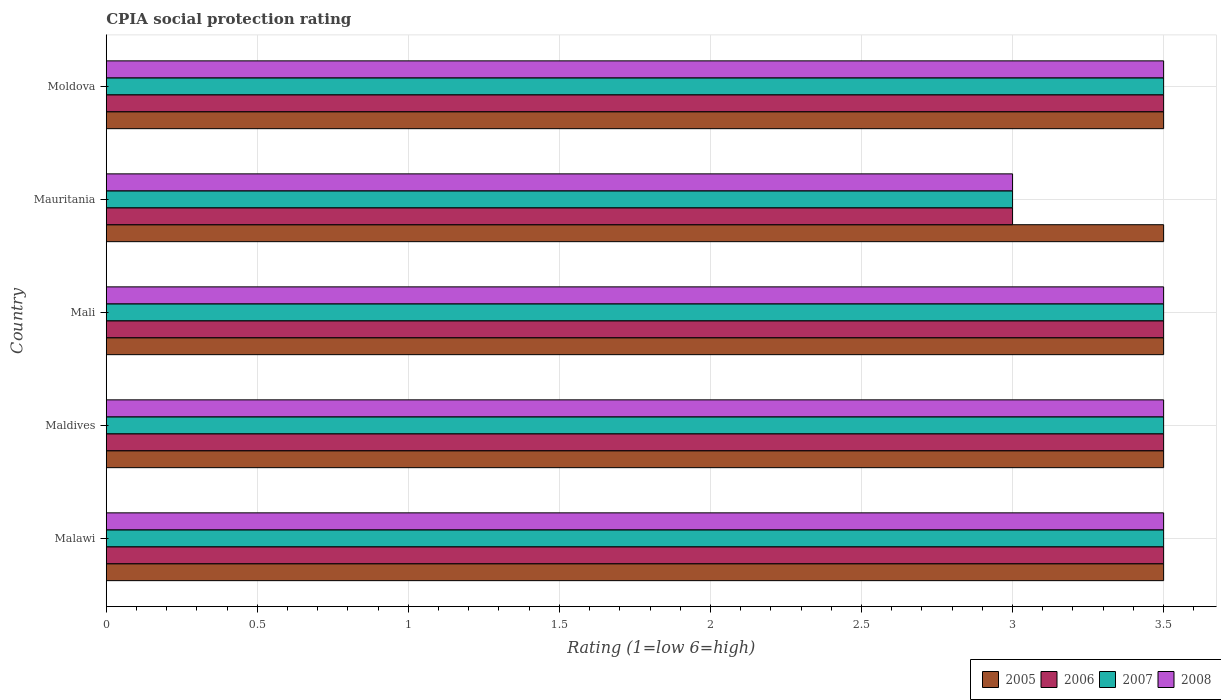Are the number of bars per tick equal to the number of legend labels?
Make the answer very short. Yes. How many bars are there on the 5th tick from the top?
Your response must be concise. 4. How many bars are there on the 2nd tick from the bottom?
Provide a short and direct response. 4. What is the label of the 2nd group of bars from the top?
Your response must be concise. Mauritania. In how many cases, is the number of bars for a given country not equal to the number of legend labels?
Your answer should be compact. 0. What is the CPIA rating in 2006 in Mauritania?
Ensure brevity in your answer.  3. In which country was the CPIA rating in 2006 maximum?
Give a very brief answer. Malawi. In which country was the CPIA rating in 2006 minimum?
Ensure brevity in your answer.  Mauritania. What is the difference between the CPIA rating in 2006 in Mauritania and the CPIA rating in 2005 in Maldives?
Your answer should be compact. -0.5. What is the average CPIA rating in 2005 per country?
Offer a terse response. 3.5. What is the difference between the CPIA rating in 2005 and CPIA rating in 2006 in Malawi?
Keep it short and to the point. 0. Is the CPIA rating in 2008 in Mali less than that in Mauritania?
Give a very brief answer. No. In how many countries, is the CPIA rating in 2007 greater than the average CPIA rating in 2007 taken over all countries?
Make the answer very short. 4. Is it the case that in every country, the sum of the CPIA rating in 2006 and CPIA rating in 2007 is greater than the sum of CPIA rating in 2008 and CPIA rating in 2005?
Keep it short and to the point. No. What does the 4th bar from the top in Mauritania represents?
Make the answer very short. 2005. What does the 1st bar from the bottom in Mali represents?
Offer a very short reply. 2005. How many bars are there?
Provide a succinct answer. 20. Are all the bars in the graph horizontal?
Your answer should be compact. Yes. How many countries are there in the graph?
Offer a terse response. 5. Are the values on the major ticks of X-axis written in scientific E-notation?
Your answer should be compact. No. Does the graph contain grids?
Provide a succinct answer. Yes. Where does the legend appear in the graph?
Offer a terse response. Bottom right. How many legend labels are there?
Your response must be concise. 4. What is the title of the graph?
Offer a very short reply. CPIA social protection rating. What is the label or title of the Y-axis?
Provide a succinct answer. Country. What is the Rating (1=low 6=high) in 2006 in Malawi?
Provide a short and direct response. 3.5. What is the Rating (1=low 6=high) in 2007 in Malawi?
Your answer should be very brief. 3.5. What is the Rating (1=low 6=high) of 2008 in Malawi?
Offer a very short reply. 3.5. What is the Rating (1=low 6=high) of 2008 in Maldives?
Offer a terse response. 3.5. What is the Rating (1=low 6=high) of 2005 in Mali?
Provide a succinct answer. 3.5. What is the Rating (1=low 6=high) of 2007 in Mali?
Keep it short and to the point. 3.5. What is the Rating (1=low 6=high) of 2008 in Mali?
Give a very brief answer. 3.5. What is the Rating (1=low 6=high) of 2007 in Mauritania?
Give a very brief answer. 3. What is the Rating (1=low 6=high) in 2008 in Moldova?
Provide a succinct answer. 3.5. Across all countries, what is the maximum Rating (1=low 6=high) in 2007?
Keep it short and to the point. 3.5. Across all countries, what is the maximum Rating (1=low 6=high) in 2008?
Ensure brevity in your answer.  3.5. Across all countries, what is the minimum Rating (1=low 6=high) of 2006?
Keep it short and to the point. 3. Across all countries, what is the minimum Rating (1=low 6=high) in 2007?
Provide a succinct answer. 3. What is the total Rating (1=low 6=high) of 2005 in the graph?
Provide a short and direct response. 17.5. What is the total Rating (1=low 6=high) of 2007 in the graph?
Keep it short and to the point. 17. What is the total Rating (1=low 6=high) in 2008 in the graph?
Your answer should be very brief. 17. What is the difference between the Rating (1=low 6=high) of 2007 in Malawi and that in Maldives?
Provide a succinct answer. 0. What is the difference between the Rating (1=low 6=high) of 2008 in Malawi and that in Maldives?
Offer a terse response. 0. What is the difference between the Rating (1=low 6=high) of 2006 in Malawi and that in Mali?
Keep it short and to the point. 0. What is the difference between the Rating (1=low 6=high) of 2007 in Malawi and that in Mali?
Provide a succinct answer. 0. What is the difference between the Rating (1=low 6=high) of 2006 in Malawi and that in Mauritania?
Your answer should be compact. 0.5. What is the difference between the Rating (1=low 6=high) in 2005 in Malawi and that in Moldova?
Ensure brevity in your answer.  0. What is the difference between the Rating (1=low 6=high) in 2006 in Malawi and that in Moldova?
Keep it short and to the point. 0. What is the difference between the Rating (1=low 6=high) of 2006 in Maldives and that in Mali?
Offer a terse response. 0. What is the difference between the Rating (1=low 6=high) in 2007 in Maldives and that in Mali?
Your response must be concise. 0. What is the difference between the Rating (1=low 6=high) in 2008 in Maldives and that in Mali?
Give a very brief answer. 0. What is the difference between the Rating (1=low 6=high) in 2007 in Maldives and that in Mauritania?
Your response must be concise. 0.5. What is the difference between the Rating (1=low 6=high) in 2006 in Maldives and that in Moldova?
Your response must be concise. 0. What is the difference between the Rating (1=low 6=high) in 2008 in Maldives and that in Moldova?
Give a very brief answer. 0. What is the difference between the Rating (1=low 6=high) of 2005 in Mali and that in Mauritania?
Your answer should be very brief. 0. What is the difference between the Rating (1=low 6=high) in 2008 in Mali and that in Mauritania?
Provide a short and direct response. 0.5. What is the difference between the Rating (1=low 6=high) in 2007 in Mali and that in Moldova?
Provide a short and direct response. 0. What is the difference between the Rating (1=low 6=high) of 2005 in Mauritania and that in Moldova?
Your response must be concise. 0. What is the difference between the Rating (1=low 6=high) of 2006 in Mauritania and that in Moldova?
Provide a succinct answer. -0.5. What is the difference between the Rating (1=low 6=high) in 2007 in Mauritania and that in Moldova?
Offer a very short reply. -0.5. What is the difference between the Rating (1=low 6=high) in 2005 in Malawi and the Rating (1=low 6=high) in 2007 in Maldives?
Your answer should be compact. 0. What is the difference between the Rating (1=low 6=high) in 2005 in Malawi and the Rating (1=low 6=high) in 2008 in Maldives?
Offer a terse response. 0. What is the difference between the Rating (1=low 6=high) in 2006 in Malawi and the Rating (1=low 6=high) in 2007 in Maldives?
Keep it short and to the point. 0. What is the difference between the Rating (1=low 6=high) of 2005 in Malawi and the Rating (1=low 6=high) of 2007 in Mali?
Give a very brief answer. 0. What is the difference between the Rating (1=low 6=high) in 2005 in Malawi and the Rating (1=low 6=high) in 2008 in Mali?
Offer a terse response. 0. What is the difference between the Rating (1=low 6=high) of 2007 in Malawi and the Rating (1=low 6=high) of 2008 in Mali?
Keep it short and to the point. 0. What is the difference between the Rating (1=low 6=high) of 2005 in Malawi and the Rating (1=low 6=high) of 2007 in Mauritania?
Your answer should be compact. 0.5. What is the difference between the Rating (1=low 6=high) in 2005 in Malawi and the Rating (1=low 6=high) in 2008 in Mauritania?
Make the answer very short. 0.5. What is the difference between the Rating (1=low 6=high) of 2006 in Malawi and the Rating (1=low 6=high) of 2008 in Mauritania?
Provide a succinct answer. 0.5. What is the difference between the Rating (1=low 6=high) in 2005 in Maldives and the Rating (1=low 6=high) in 2006 in Mali?
Give a very brief answer. 0. What is the difference between the Rating (1=low 6=high) of 2005 in Maldives and the Rating (1=low 6=high) of 2008 in Mali?
Provide a short and direct response. 0. What is the difference between the Rating (1=low 6=high) in 2006 in Maldives and the Rating (1=low 6=high) in 2007 in Mali?
Give a very brief answer. 0. What is the difference between the Rating (1=low 6=high) in 2006 in Maldives and the Rating (1=low 6=high) in 2008 in Mali?
Give a very brief answer. 0. What is the difference between the Rating (1=low 6=high) in 2007 in Maldives and the Rating (1=low 6=high) in 2008 in Mali?
Give a very brief answer. 0. What is the difference between the Rating (1=low 6=high) of 2005 in Maldives and the Rating (1=low 6=high) of 2006 in Mauritania?
Make the answer very short. 0.5. What is the difference between the Rating (1=low 6=high) of 2005 in Maldives and the Rating (1=low 6=high) of 2007 in Mauritania?
Your answer should be very brief. 0.5. What is the difference between the Rating (1=low 6=high) of 2006 in Maldives and the Rating (1=low 6=high) of 2007 in Mauritania?
Provide a short and direct response. 0.5. What is the difference between the Rating (1=low 6=high) of 2005 in Maldives and the Rating (1=low 6=high) of 2006 in Moldova?
Your answer should be very brief. 0. What is the difference between the Rating (1=low 6=high) of 2005 in Maldives and the Rating (1=low 6=high) of 2007 in Moldova?
Your answer should be very brief. 0. What is the difference between the Rating (1=low 6=high) of 2005 in Maldives and the Rating (1=low 6=high) of 2008 in Moldova?
Your answer should be compact. 0. What is the difference between the Rating (1=low 6=high) in 2006 in Maldives and the Rating (1=low 6=high) in 2008 in Moldova?
Make the answer very short. 0. What is the difference between the Rating (1=low 6=high) of 2007 in Maldives and the Rating (1=low 6=high) of 2008 in Moldova?
Your answer should be very brief. 0. What is the difference between the Rating (1=low 6=high) in 2005 in Mali and the Rating (1=low 6=high) in 2007 in Mauritania?
Ensure brevity in your answer.  0.5. What is the difference between the Rating (1=low 6=high) of 2006 in Mali and the Rating (1=low 6=high) of 2008 in Mauritania?
Your response must be concise. 0.5. What is the difference between the Rating (1=low 6=high) in 2007 in Mali and the Rating (1=low 6=high) in 2008 in Mauritania?
Offer a very short reply. 0.5. What is the difference between the Rating (1=low 6=high) in 2005 in Mali and the Rating (1=low 6=high) in 2007 in Moldova?
Your answer should be very brief. 0. What is the difference between the Rating (1=low 6=high) in 2005 in Mali and the Rating (1=low 6=high) in 2008 in Moldova?
Provide a short and direct response. 0. What is the difference between the Rating (1=low 6=high) of 2006 in Mali and the Rating (1=low 6=high) of 2007 in Moldova?
Your answer should be very brief. 0. What is the difference between the Rating (1=low 6=high) in 2006 in Mali and the Rating (1=low 6=high) in 2008 in Moldova?
Your answer should be very brief. 0. What is the difference between the Rating (1=low 6=high) of 2007 in Mali and the Rating (1=low 6=high) of 2008 in Moldova?
Give a very brief answer. 0. What is the difference between the Rating (1=low 6=high) of 2005 in Mauritania and the Rating (1=low 6=high) of 2006 in Moldova?
Your answer should be compact. 0. What is the difference between the Rating (1=low 6=high) of 2006 in Mauritania and the Rating (1=low 6=high) of 2007 in Moldova?
Your answer should be compact. -0.5. What is the difference between the Rating (1=low 6=high) in 2006 in Mauritania and the Rating (1=low 6=high) in 2008 in Moldova?
Offer a terse response. -0.5. What is the difference between the Rating (1=low 6=high) of 2007 in Mauritania and the Rating (1=low 6=high) of 2008 in Moldova?
Your answer should be very brief. -0.5. What is the average Rating (1=low 6=high) of 2005 per country?
Give a very brief answer. 3.5. What is the average Rating (1=low 6=high) in 2007 per country?
Offer a very short reply. 3.4. What is the difference between the Rating (1=low 6=high) of 2005 and Rating (1=low 6=high) of 2006 in Malawi?
Your answer should be very brief. 0. What is the difference between the Rating (1=low 6=high) of 2005 and Rating (1=low 6=high) of 2008 in Malawi?
Your response must be concise. 0. What is the difference between the Rating (1=low 6=high) of 2006 and Rating (1=low 6=high) of 2007 in Malawi?
Keep it short and to the point. 0. What is the difference between the Rating (1=low 6=high) in 2006 and Rating (1=low 6=high) in 2008 in Malawi?
Provide a succinct answer. 0. What is the difference between the Rating (1=low 6=high) in 2005 and Rating (1=low 6=high) in 2006 in Maldives?
Ensure brevity in your answer.  0. What is the difference between the Rating (1=low 6=high) in 2006 and Rating (1=low 6=high) in 2007 in Maldives?
Your answer should be compact. 0. What is the difference between the Rating (1=low 6=high) in 2006 and Rating (1=low 6=high) in 2008 in Maldives?
Your answer should be compact. 0. What is the difference between the Rating (1=low 6=high) in 2006 and Rating (1=low 6=high) in 2007 in Mali?
Make the answer very short. 0. What is the difference between the Rating (1=low 6=high) in 2005 and Rating (1=low 6=high) in 2006 in Mauritania?
Your answer should be compact. 0.5. What is the difference between the Rating (1=low 6=high) in 2005 and Rating (1=low 6=high) in 2008 in Mauritania?
Your response must be concise. 0.5. What is the difference between the Rating (1=low 6=high) of 2006 and Rating (1=low 6=high) of 2007 in Mauritania?
Provide a short and direct response. 0. What is the difference between the Rating (1=low 6=high) of 2006 and Rating (1=low 6=high) of 2008 in Mauritania?
Ensure brevity in your answer.  0. What is the difference between the Rating (1=low 6=high) in 2005 and Rating (1=low 6=high) in 2006 in Moldova?
Make the answer very short. 0. What is the difference between the Rating (1=low 6=high) in 2005 and Rating (1=low 6=high) in 2007 in Moldova?
Ensure brevity in your answer.  0. What is the difference between the Rating (1=low 6=high) in 2006 and Rating (1=low 6=high) in 2007 in Moldova?
Offer a terse response. 0. What is the ratio of the Rating (1=low 6=high) of 2007 in Malawi to that in Maldives?
Provide a succinct answer. 1. What is the ratio of the Rating (1=low 6=high) of 2005 in Malawi to that in Mali?
Give a very brief answer. 1. What is the ratio of the Rating (1=low 6=high) in 2007 in Malawi to that in Mali?
Make the answer very short. 1. What is the ratio of the Rating (1=low 6=high) of 2007 in Malawi to that in Mauritania?
Ensure brevity in your answer.  1.17. What is the ratio of the Rating (1=low 6=high) of 2007 in Malawi to that in Moldova?
Provide a succinct answer. 1. What is the ratio of the Rating (1=low 6=high) in 2005 in Maldives to that in Mauritania?
Provide a succinct answer. 1. What is the ratio of the Rating (1=low 6=high) of 2008 in Maldives to that in Mauritania?
Your response must be concise. 1.17. What is the ratio of the Rating (1=low 6=high) in 2005 in Maldives to that in Moldova?
Ensure brevity in your answer.  1. What is the ratio of the Rating (1=low 6=high) of 2006 in Maldives to that in Moldova?
Offer a terse response. 1. What is the ratio of the Rating (1=low 6=high) in 2007 in Maldives to that in Moldova?
Offer a terse response. 1. What is the ratio of the Rating (1=low 6=high) in 2008 in Maldives to that in Moldova?
Provide a succinct answer. 1. What is the ratio of the Rating (1=low 6=high) in 2007 in Mali to that in Mauritania?
Offer a terse response. 1.17. What is the ratio of the Rating (1=low 6=high) of 2006 in Mali to that in Moldova?
Make the answer very short. 1. What is the ratio of the Rating (1=low 6=high) in 2007 in Mali to that in Moldova?
Give a very brief answer. 1. What is the ratio of the Rating (1=low 6=high) in 2008 in Mali to that in Moldova?
Make the answer very short. 1. What is the ratio of the Rating (1=low 6=high) of 2006 in Mauritania to that in Moldova?
Give a very brief answer. 0.86. What is the difference between the highest and the second highest Rating (1=low 6=high) of 2005?
Offer a very short reply. 0. What is the difference between the highest and the second highest Rating (1=low 6=high) of 2007?
Offer a terse response. 0. What is the difference between the highest and the lowest Rating (1=low 6=high) of 2005?
Your answer should be compact. 0. What is the difference between the highest and the lowest Rating (1=low 6=high) of 2008?
Your answer should be very brief. 0.5. 